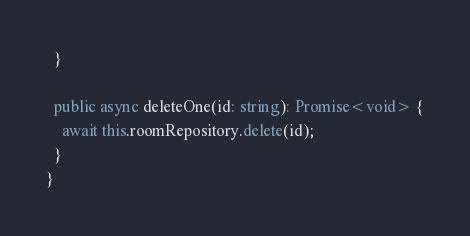<code> <loc_0><loc_0><loc_500><loc_500><_TypeScript_>  }

  public async deleteOne(id: string): Promise<void> {
    await this.roomRepository.delete(id);
  }
}
</code> 